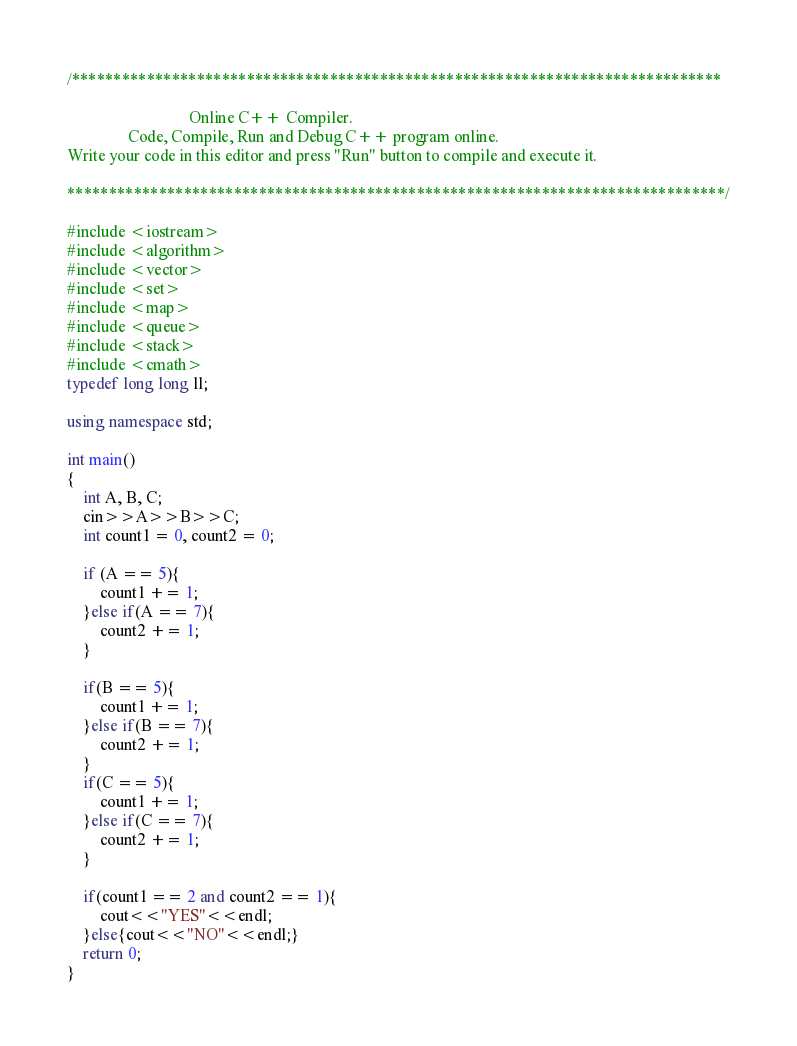<code> <loc_0><loc_0><loc_500><loc_500><_C++_>/******************************************************************************

                              Online C++ Compiler.
               Code, Compile, Run and Debug C++ program online.
Write your code in this editor and press "Run" button to compile and execute it.

*******************************************************************************/

#include <iostream>
#include <algorithm>
#include <vector>
#include <set>
#include <map>
#include <queue>
#include <stack>
#include <cmath>
typedef long long ll;

using namespace std;

int main()
{
    int A, B, C;
    cin>>A>>B>>C;
    int count1 = 0, count2 = 0;
    
    if (A == 5){
        count1 += 1;
    }else if(A == 7){
        count2 += 1;
    }
    
    if(B == 5){
        count1 += 1;
    }else if(B == 7){
        count2 += 1;
    }
    if(C == 5){
        count1 += 1;
    }else if(C == 7){
        count2 += 1;
    }
    
    if(count1 == 2 and count2 == 1){
        cout<<"YES"<<endl;
    }else{cout<<"NO"<<endl;}
    return 0;
}
</code> 